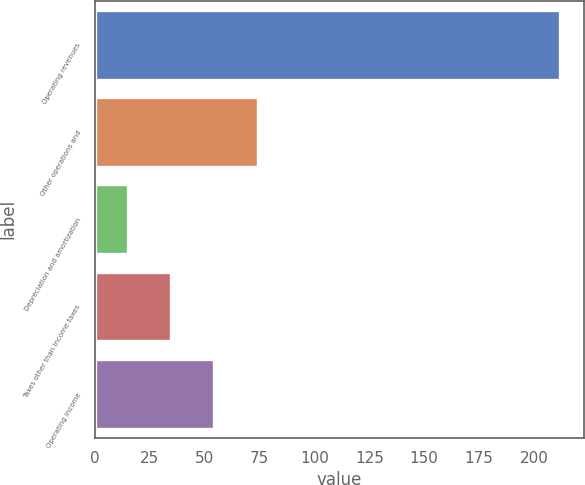Convert chart to OTSL. <chart><loc_0><loc_0><loc_500><loc_500><bar_chart><fcel>Operating revenues<fcel>Other operations and<fcel>Depreciation and amortization<fcel>Taxes other than income taxes<fcel>Operating income<nl><fcel>212<fcel>74.1<fcel>15<fcel>34.7<fcel>54.4<nl></chart> 